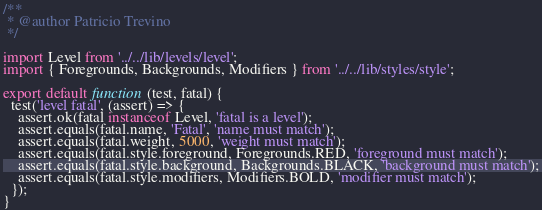Convert code to text. <code><loc_0><loc_0><loc_500><loc_500><_JavaScript_>/**
 * @author Patricio Trevino
 */

import Level from '../../lib/levels/level';
import { Foregrounds, Backgrounds, Modifiers } from '../../lib/styles/style';

export default function (test, fatal) {
  test('level fatal', (assert) => {
    assert.ok(fatal instanceof Level, 'fatal is a level');
    assert.equals(fatal.name, 'Fatal', 'name must match');
    assert.equals(fatal.weight, 5000, 'weight must match');
    assert.equals(fatal.style.foreground, Foregrounds.RED, 'foreground must match');
    assert.equals(fatal.style.background, Backgrounds.BLACK, 'background must match');
    assert.equals(fatal.style.modifiers, Modifiers.BOLD, 'modifier must match');
  });
}
</code> 